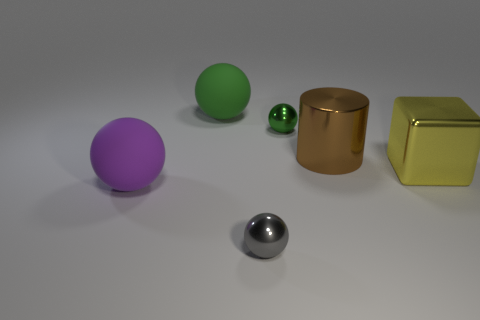There is a tiny gray thing that is right of the large matte thing in front of the yellow thing; what shape is it?
Provide a short and direct response. Sphere. What number of objects are large matte things behind the purple ball or shiny objects that are on the left side of the brown cylinder?
Your answer should be very brief. 3. What is the shape of the big green thing that is made of the same material as the large purple ball?
Keep it short and to the point. Sphere. Is there any other thing that is the same color as the shiny cylinder?
Keep it short and to the point. No. There is a tiny gray object that is the same shape as the purple rubber object; what is it made of?
Keep it short and to the point. Metal. What number of other things are there of the same size as the gray thing?
Provide a short and direct response. 1. What is the purple thing made of?
Provide a succinct answer. Rubber. Is the number of tiny things that are on the right side of the gray ball greater than the number of blue rubber blocks?
Offer a terse response. Yes. Are there any large blue things?
Your response must be concise. No. How many other objects are there of the same shape as the big brown thing?
Provide a short and direct response. 0. 